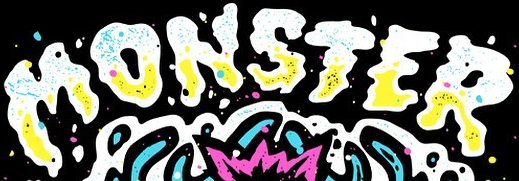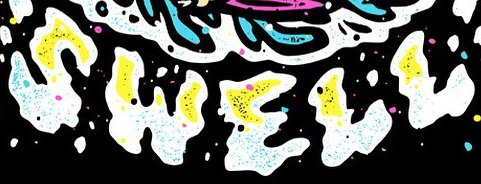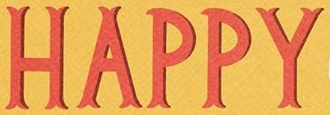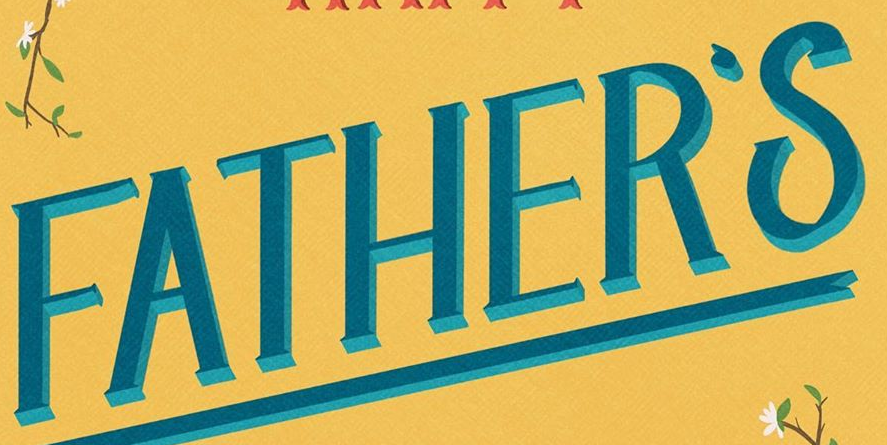Read the text content from these images in order, separated by a semicolon. MONSTER; SWELL; HAPPY; FATHER'S 